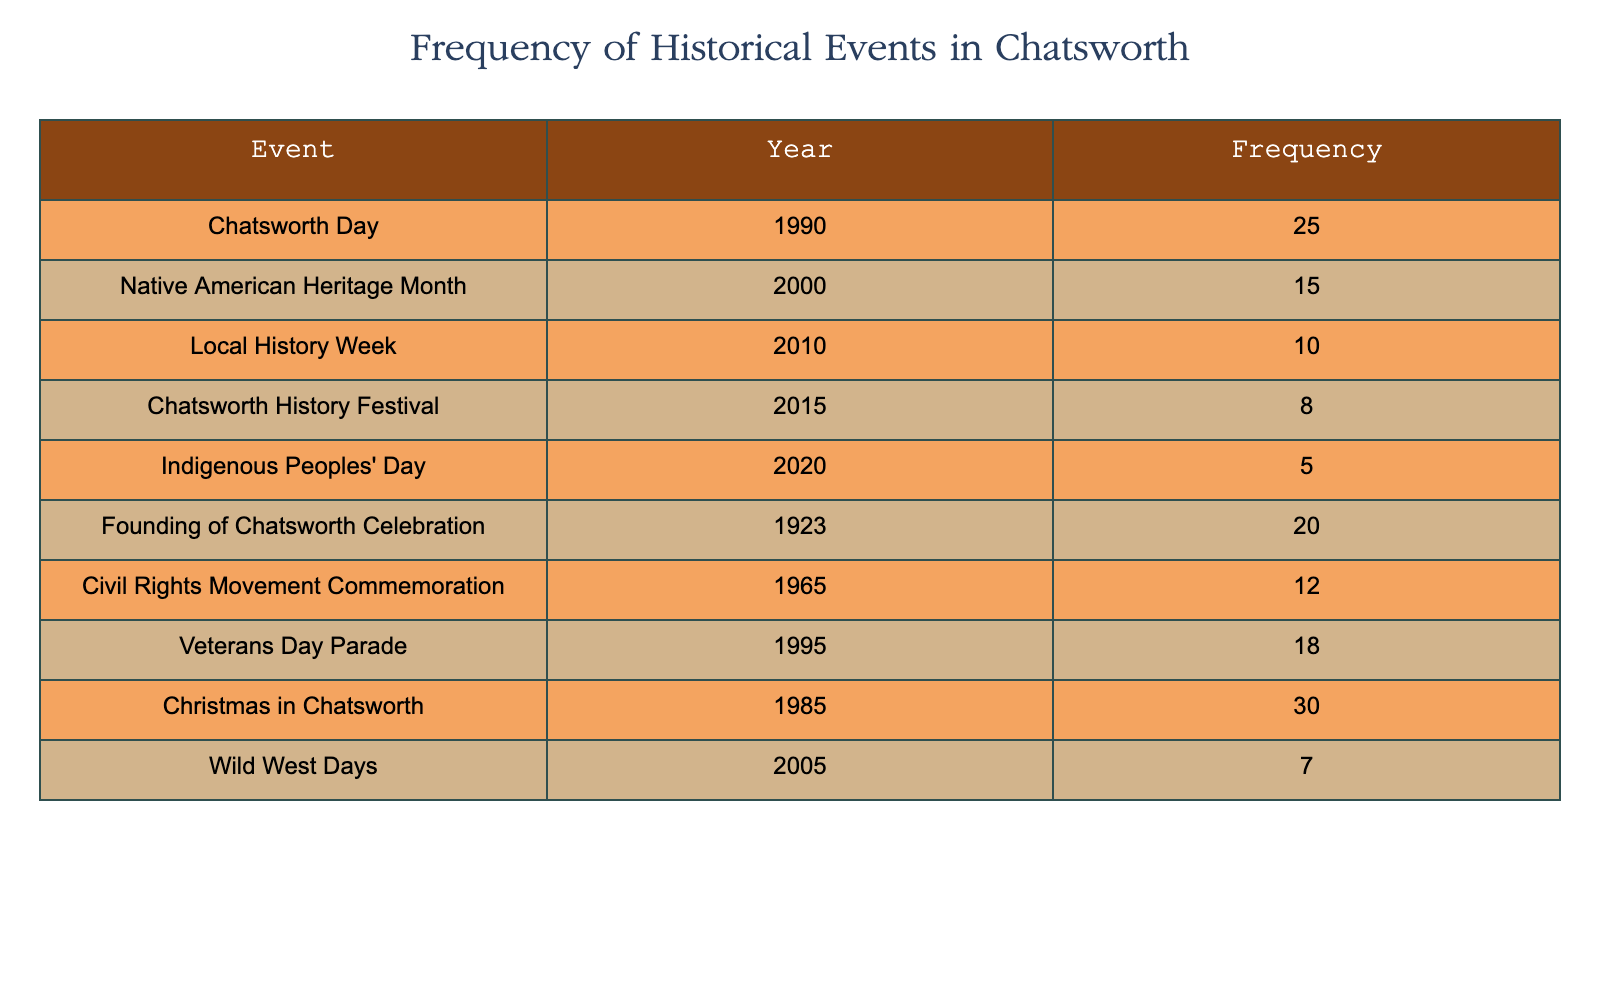What event had the highest frequency? By looking at the "Frequency" column, the event "Christmas in Chatsworth" has the highest frequency value of 30.
Answer: 30 Which event was celebrated in the year 1995? Referencing the "Year" column, the event "Veterans Day Parade" corresponds to the year 1995.
Answer: Veterans Day Parade What is the frequency of the "Indigenous Peoples' Day"? From the table, the frequency associated with "Indigenous Peoples' Day" is listed as 5.
Answer: 5 What is the total frequency of events celebrated before 2000? Summing the frequency of the respective events before 2000: "Founding of Chatsworth Celebration" (20) + "Christmas in Chatsworth" (30) + "Veterans Day Parade" (18) + "Civil Rights Movement Commemoration" (12) yields a total of 80.
Answer: 80 Did any events celebrated in 2005 have a frequency higher than 10? Checking the event "Wild West Days" for 2005, its frequency is 7, which is less than 10. Thus, the answer is no.
Answer: No How many events in total were celebrated after 2010? The events celebrated after 2010 are "Chatsworth History Festival" (8), "Indigenous Peoples' Day" (5), and there are 3 events total: 8 + 5 = 13.
Answer: 3 What is the average frequency of events between 2010 to 2020? The events during this period include "Local History Week" (10), "Chatsworth History Festival" (8), and "Indigenous Peoples' Day" (5). Adding those gives 10 + 8 + 5 = 23. There are 3 events; the average is 23/3 = 7.67.
Answer: 7.67 Which event celebrated in 1923 had a frequency of over 15? The event "Founding of Chatsworth Celebration", celebrated in 1923, has a frequency of 20, which is indeed over 15.
Answer: Yes How many years apart are "Chatsworth Day" and "Veterans Day Parade"? "Chatsworth Day" was celebrated in 1990 and "Veterans Day Parade" in 1995. The difference between the years is 1995 - 1990 = 5 years.
Answer: 5 years 